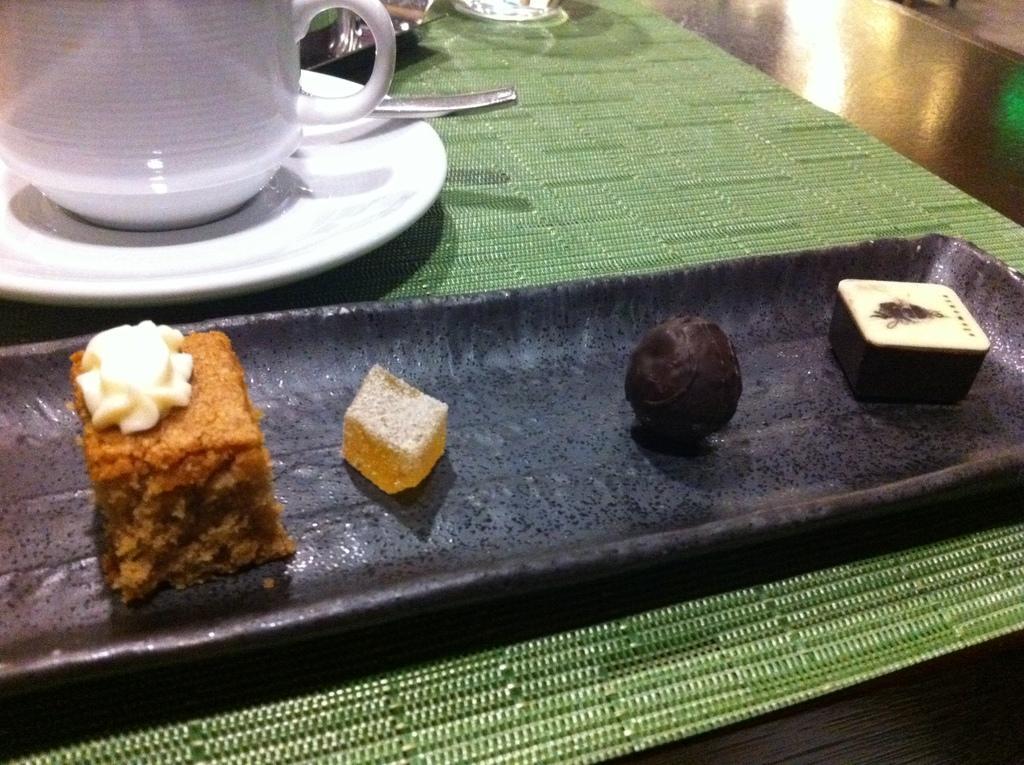How would you summarize this image in a sentence or two? On this table we can able to see green carpet, plate, cup, food in a tray. 